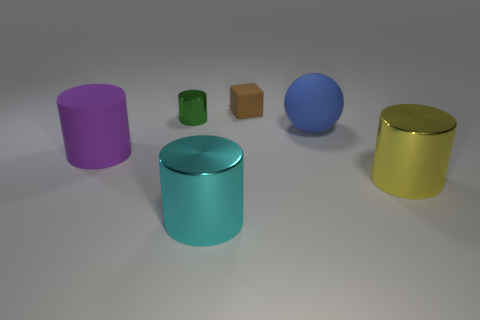There is a metal cylinder that is on the right side of the cyan thing; does it have the same size as the brown matte thing?
Your answer should be very brief. No. What is the size of the rubber thing that is the same shape as the yellow shiny object?
Offer a very short reply. Large. There is a blue object that is the same size as the yellow metallic thing; what is its material?
Make the answer very short. Rubber. There is a large purple thing that is the same shape as the large yellow object; what material is it?
Ensure brevity in your answer.  Rubber. What number of other objects are the same size as the rubber cube?
Your answer should be compact. 1. There is a cyan object; what shape is it?
Give a very brief answer. Cylinder. What color is the large cylinder that is left of the rubber block and to the right of the tiny green cylinder?
Your answer should be compact. Cyan. What is the large cyan cylinder made of?
Provide a short and direct response. Metal. What is the shape of the large matte thing that is on the left side of the tiny matte cube?
Make the answer very short. Cylinder. What color is the other rubber thing that is the same size as the purple object?
Your answer should be very brief. Blue. 